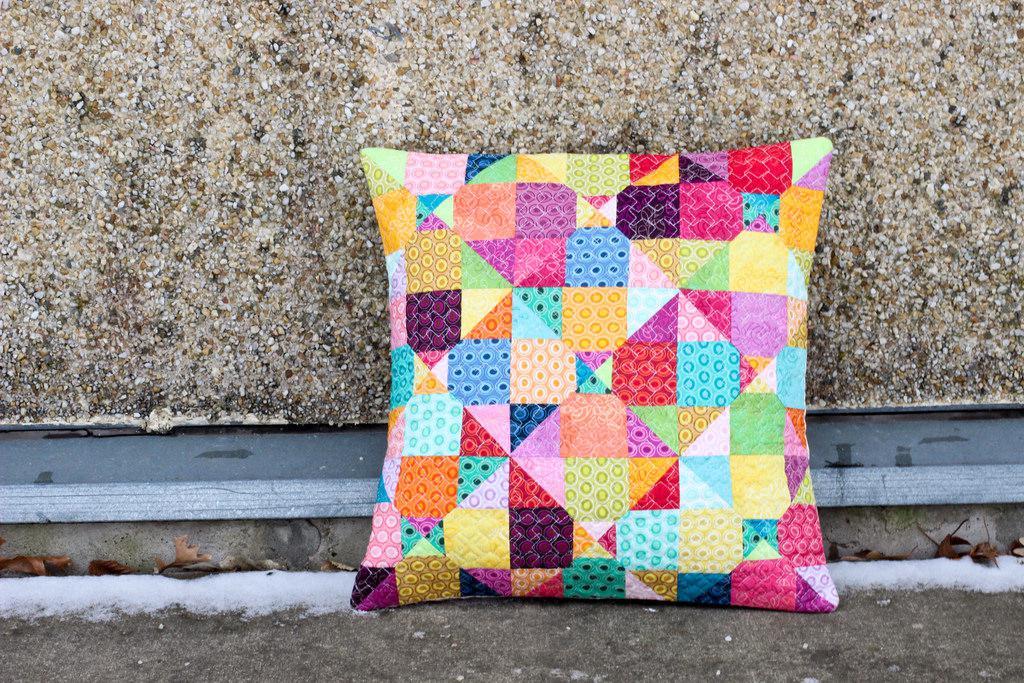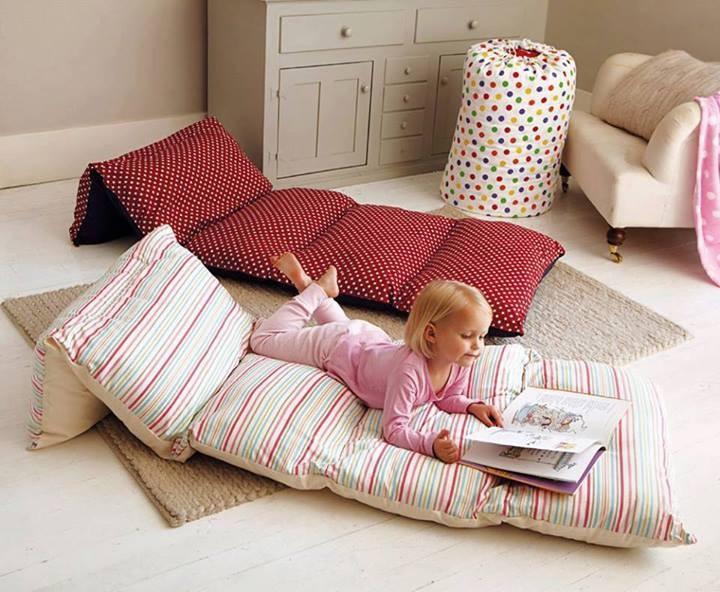The first image is the image on the left, the second image is the image on the right. Evaluate the accuracy of this statement regarding the images: "In each of the right photos, there are two children lying on the mattresses.". Is it true? Answer yes or no. No. The first image is the image on the left, the second image is the image on the right. For the images displayed, is the sentence "there are two children laying on mats on a wood floor" factually correct? Answer yes or no. No. 